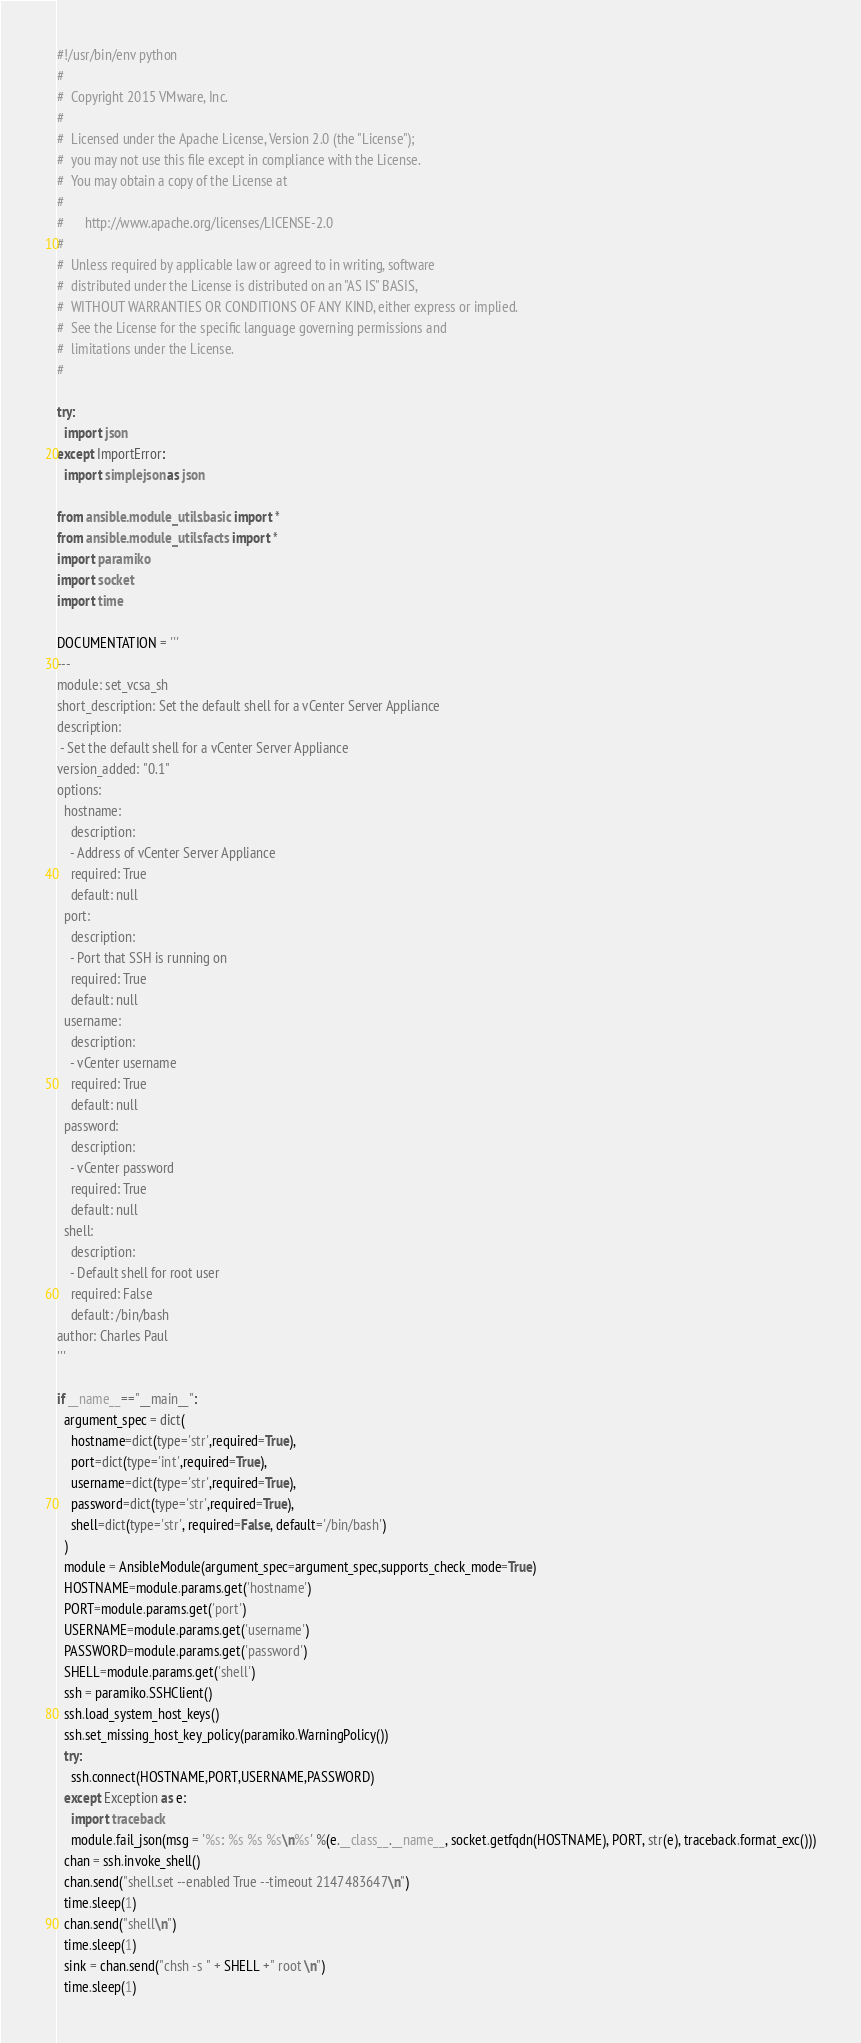<code> <loc_0><loc_0><loc_500><loc_500><_Python_>#!/usr/bin/env python
#
#  Copyright 2015 VMware, Inc.
#
#  Licensed under the Apache License, Version 2.0 (the "License");
#  you may not use this file except in compliance with the License.
#  You may obtain a copy of the License at
#
#      http://www.apache.org/licenses/LICENSE-2.0
#
#  Unless required by applicable law or agreed to in writing, software
#  distributed under the License is distributed on an "AS IS" BASIS,
#  WITHOUT WARRANTIES OR CONDITIONS OF ANY KIND, either express or implied.
#  See the License for the specific language governing permissions and
#  limitations under the License.
#

try:
  import json
except ImportError:
  import simplejson as json

from ansible.module_utils.basic import *
from ansible.module_utils.facts import *
import paramiko
import socket
import time

DOCUMENTATION = '''
---
module: set_vcsa_sh
short_description: Set the default shell for a vCenter Server Appliance
description:
 - Set the default shell for a vCenter Server Appliance
version_added: "0.1"
options:
  hostname:
    description:
    - Address of vCenter Server Appliance
    required: True
    default: null
  port:
    description:
    - Port that SSH is running on
    required: True
    default: null
  username:
    description:
    - vCenter username
    required: True
    default: null
  password:
    description:
    - vCenter password
    required: True
    default: null
  shell:
    description:
    - Default shell for root user
    required: False
    default: /bin/bash
author: Charles Paul
'''

if __name__=="__main__":
  argument_spec = dict(
    hostname=dict(type='str',required=True),
    port=dict(type='int',required=True),
    username=dict(type='str',required=True),
    password=dict(type='str',required=True),
    shell=dict(type='str', required=False, default='/bin/bash')
  )
  module = AnsibleModule(argument_spec=argument_spec,supports_check_mode=True)
  HOSTNAME=module.params.get('hostname')
  PORT=module.params.get('port')
  USERNAME=module.params.get('username')
  PASSWORD=module.params.get('password')
  SHELL=module.params.get('shell')
  ssh = paramiko.SSHClient()
  ssh.load_system_host_keys()
  ssh.set_missing_host_key_policy(paramiko.WarningPolicy())
  try:
    ssh.connect(HOSTNAME,PORT,USERNAME,PASSWORD)
  except Exception as e:
    import traceback
    module.fail_json(msg = '%s: %s %s %s\n%s' %(e.__class__.__name__, socket.getfqdn(HOSTNAME), PORT, str(e), traceback.format_exc()))
  chan = ssh.invoke_shell()
  chan.send("shell.set --enabled True --timeout 2147483647\n")
  time.sleep(1)
  chan.send("shell\n")
  time.sleep(1)
  sink = chan.send("chsh -s " + SHELL +" root \n")
  time.sleep(1)
</code> 